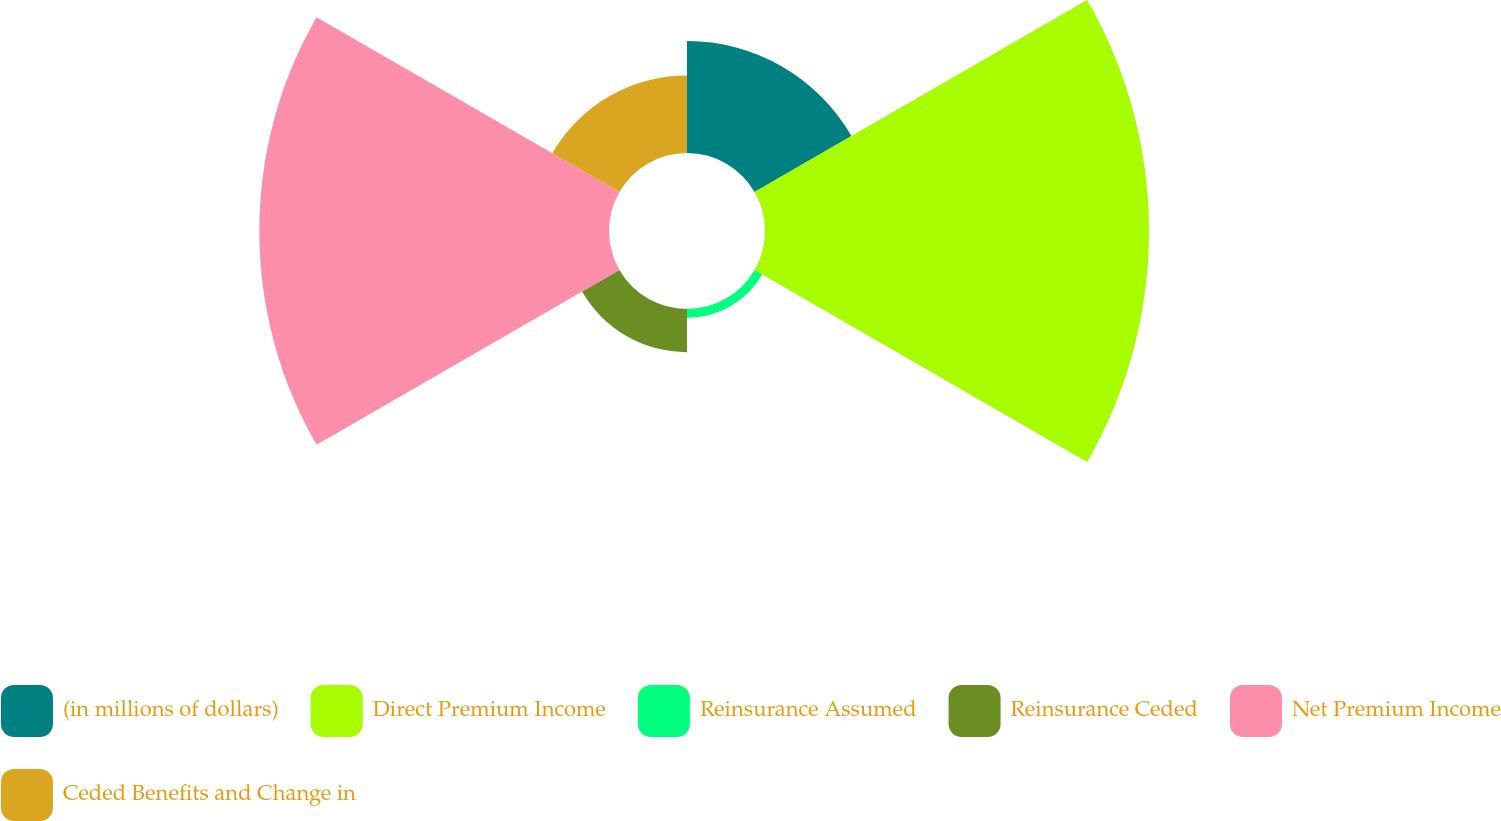Convert chart. <chart><loc_0><loc_0><loc_500><loc_500><pie_chart><fcel>(in millions of dollars)<fcel>Direct Premium Income<fcel>Reinsurance Assumed<fcel>Reinsurance Ceded<fcel>Net Premium Income<fcel>Ceded Benefits and Change in<nl><fcel>11.48%<fcel>39.38%<fcel>0.9%<fcel>4.43%<fcel>35.86%<fcel>7.95%<nl></chart> 